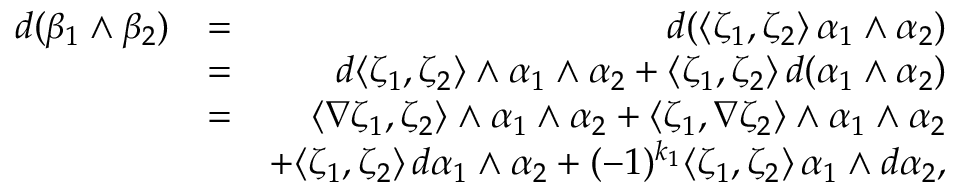Convert formula to latex. <formula><loc_0><loc_0><loc_500><loc_500>\begin{array} { r l r } { d ( \beta _ { 1 } \wedge \beta _ { 2 } ) } & { = } & { d ( \langle \zeta _ { 1 } , \zeta _ { 2 } \rangle \, \alpha _ { 1 } \wedge \alpha _ { 2 } ) } \\ & { = } & { d \langle \zeta _ { 1 } , \zeta _ { 2 } \rangle \wedge \alpha _ { 1 } \wedge \alpha _ { 2 } + \langle \zeta _ { 1 } , \zeta _ { 2 } \rangle \, d ( \alpha _ { 1 } \wedge \alpha _ { 2 } ) } \\ & { = } & { \langle \nabla \zeta _ { 1 } , \zeta _ { 2 } \rangle \wedge \alpha _ { 1 } \wedge \alpha _ { 2 } + \langle \zeta _ { 1 } , \nabla \zeta _ { 2 } \rangle \wedge \alpha _ { 1 } \wedge \alpha _ { 2 } } \\ & { + \langle \zeta _ { 1 } , \zeta _ { 2 } \rangle \, d \alpha _ { 1 } \wedge \alpha _ { 2 } + ( - 1 ) ^ { k _ { 1 } } \langle \zeta _ { 1 } , \zeta _ { 2 } \rangle \, \alpha _ { 1 } \wedge d \alpha _ { 2 } , } \end{array}</formula> 